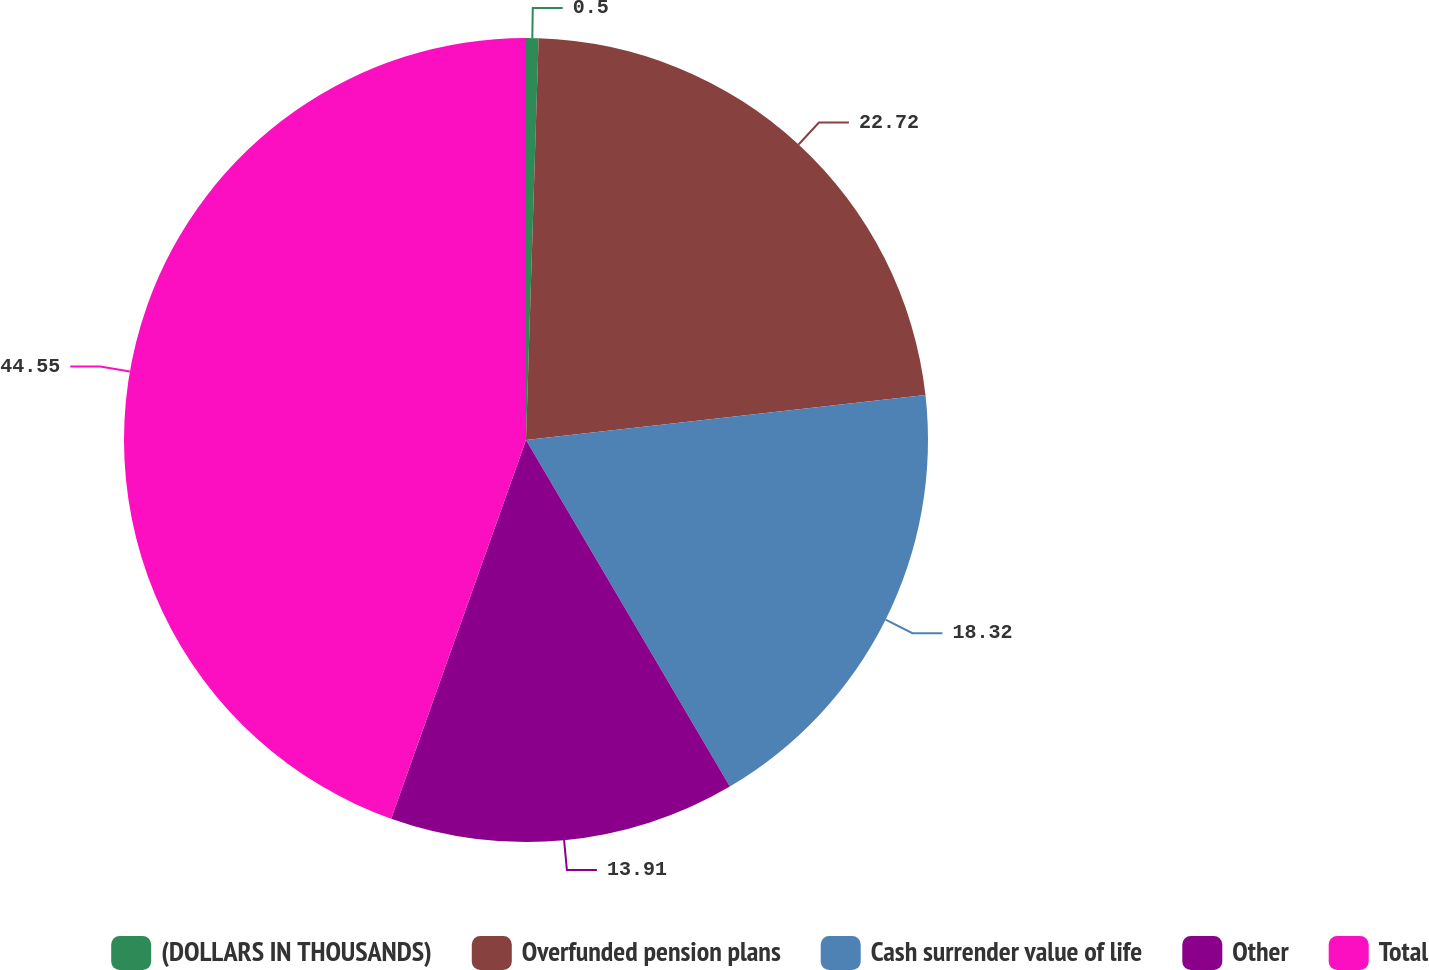Convert chart to OTSL. <chart><loc_0><loc_0><loc_500><loc_500><pie_chart><fcel>(DOLLARS IN THOUSANDS)<fcel>Overfunded pension plans<fcel>Cash surrender value of life<fcel>Other<fcel>Total<nl><fcel>0.5%<fcel>22.72%<fcel>18.32%<fcel>13.91%<fcel>44.56%<nl></chart> 